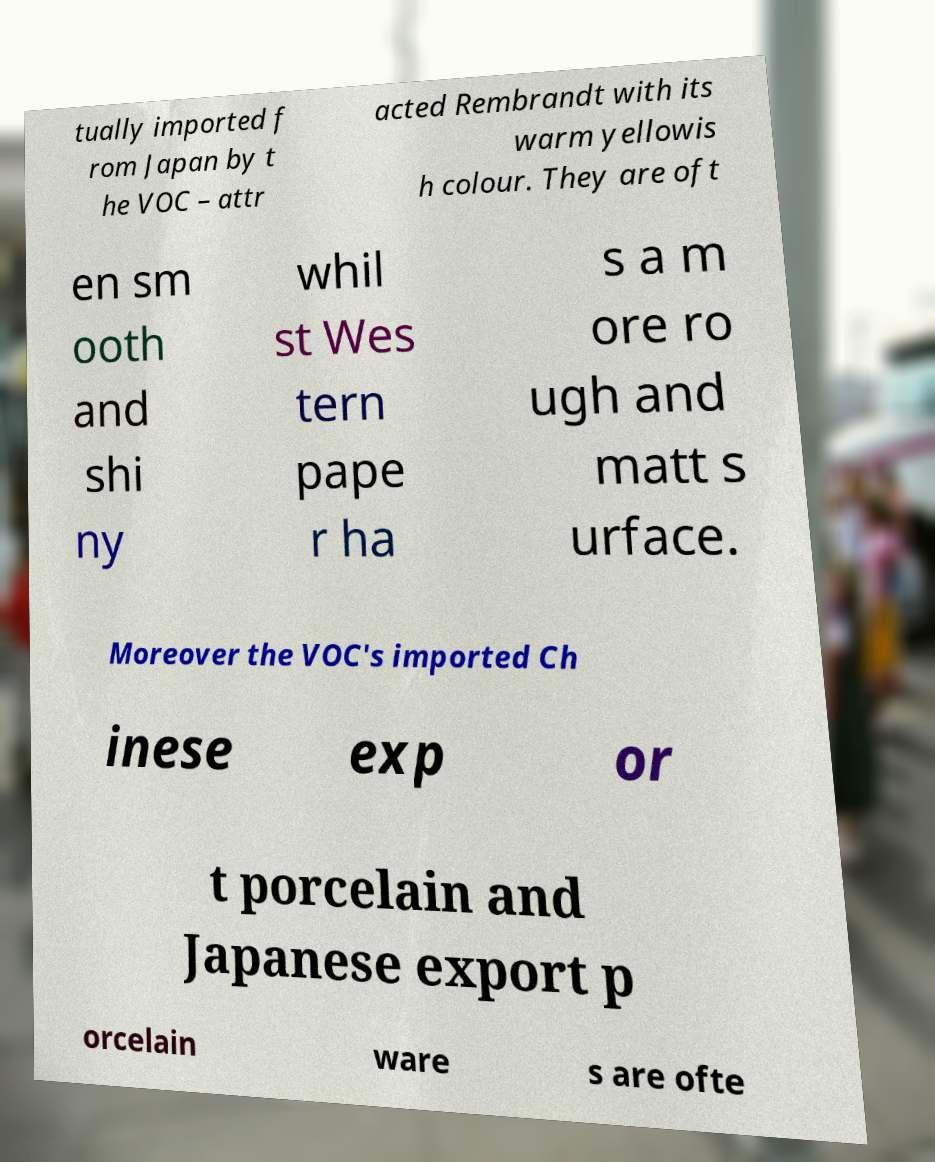Please identify and transcribe the text found in this image. tually imported f rom Japan by t he VOC – attr acted Rembrandt with its warm yellowis h colour. They are oft en sm ooth and shi ny whil st Wes tern pape r ha s a m ore ro ugh and matt s urface. Moreover the VOC's imported Ch inese exp or t porcelain and Japanese export p orcelain ware s are ofte 